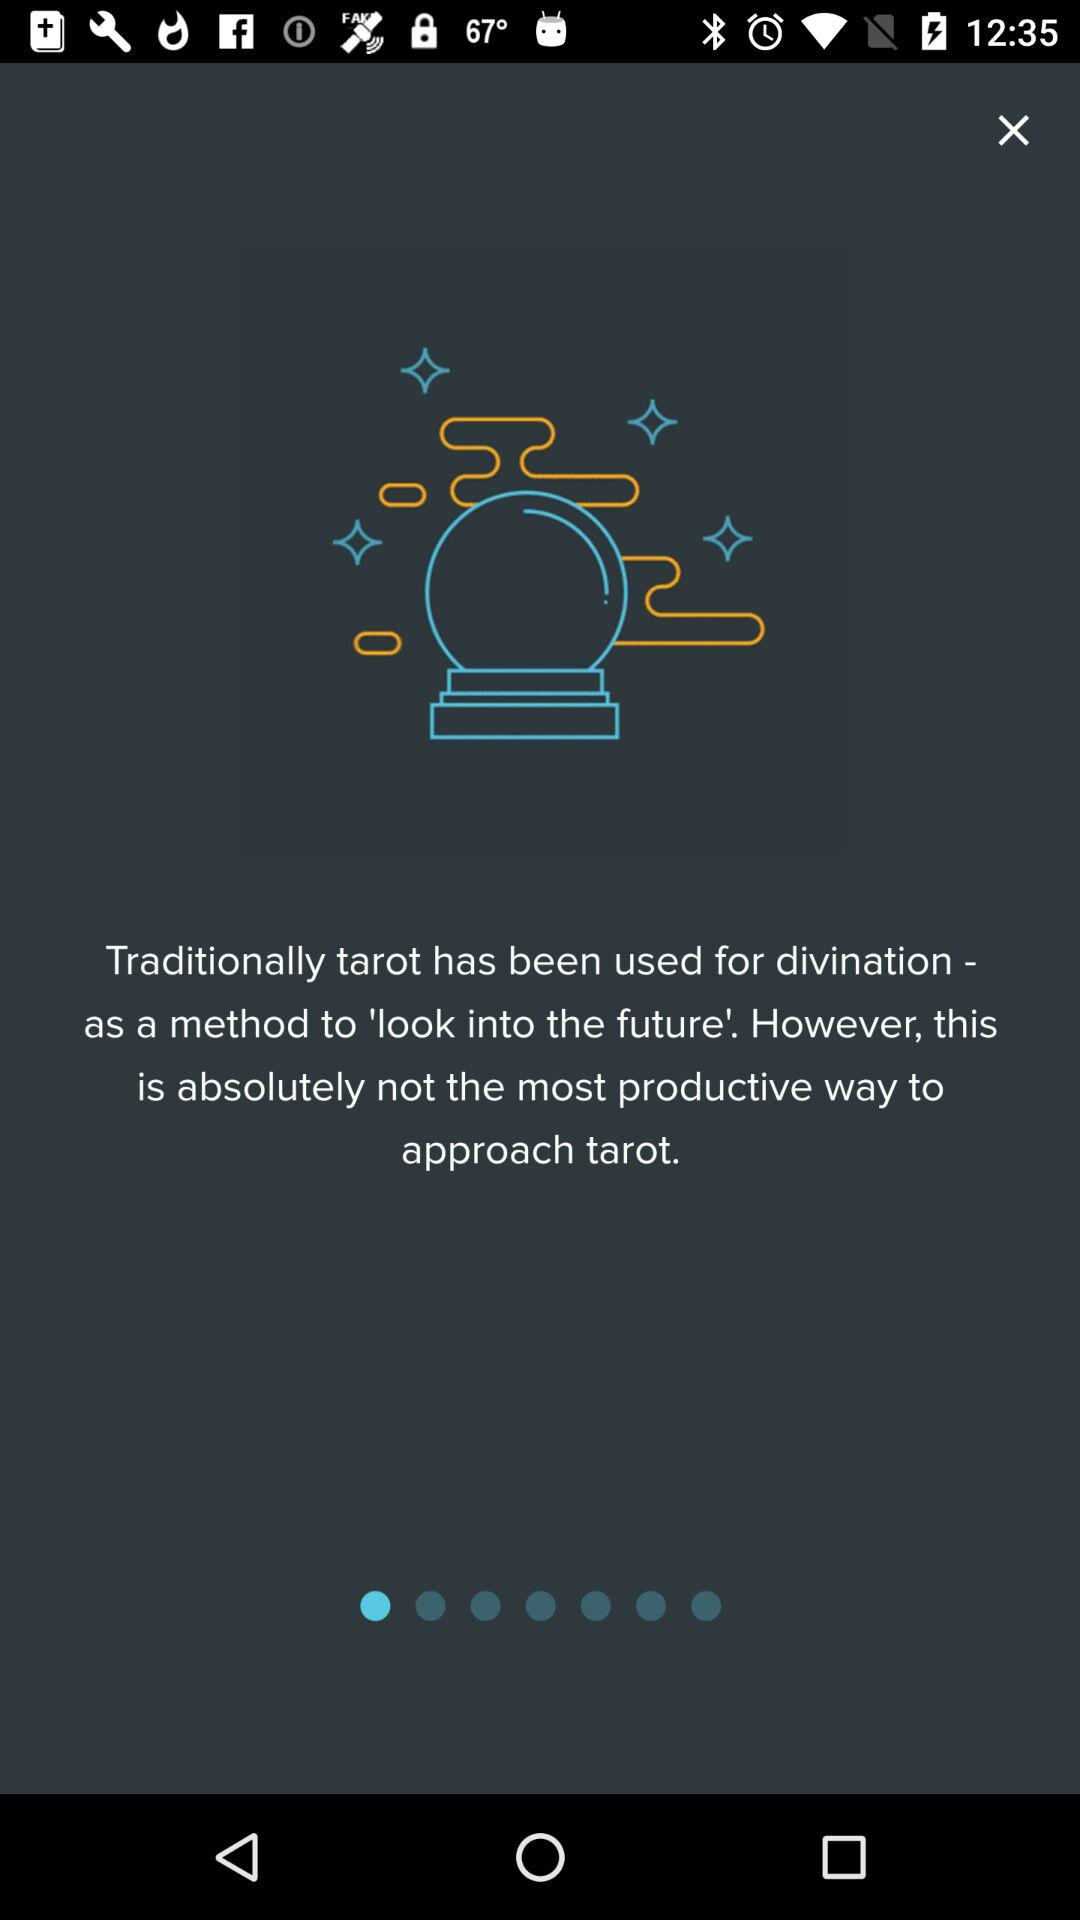What is the application name?
When the provided information is insufficient, respond with <no answer>. <no answer> 